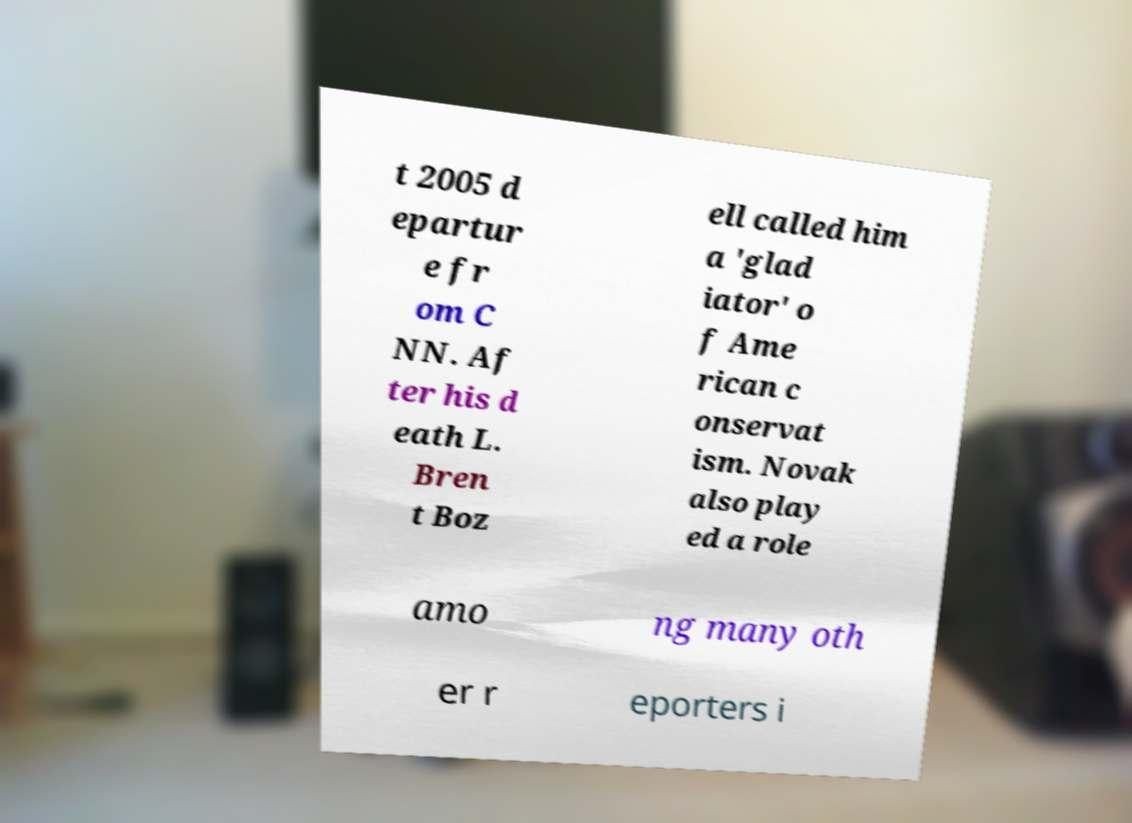Could you assist in decoding the text presented in this image and type it out clearly? t 2005 d epartur e fr om C NN. Af ter his d eath L. Bren t Boz ell called him a 'glad iator' o f Ame rican c onservat ism. Novak also play ed a role amo ng many oth er r eporters i 